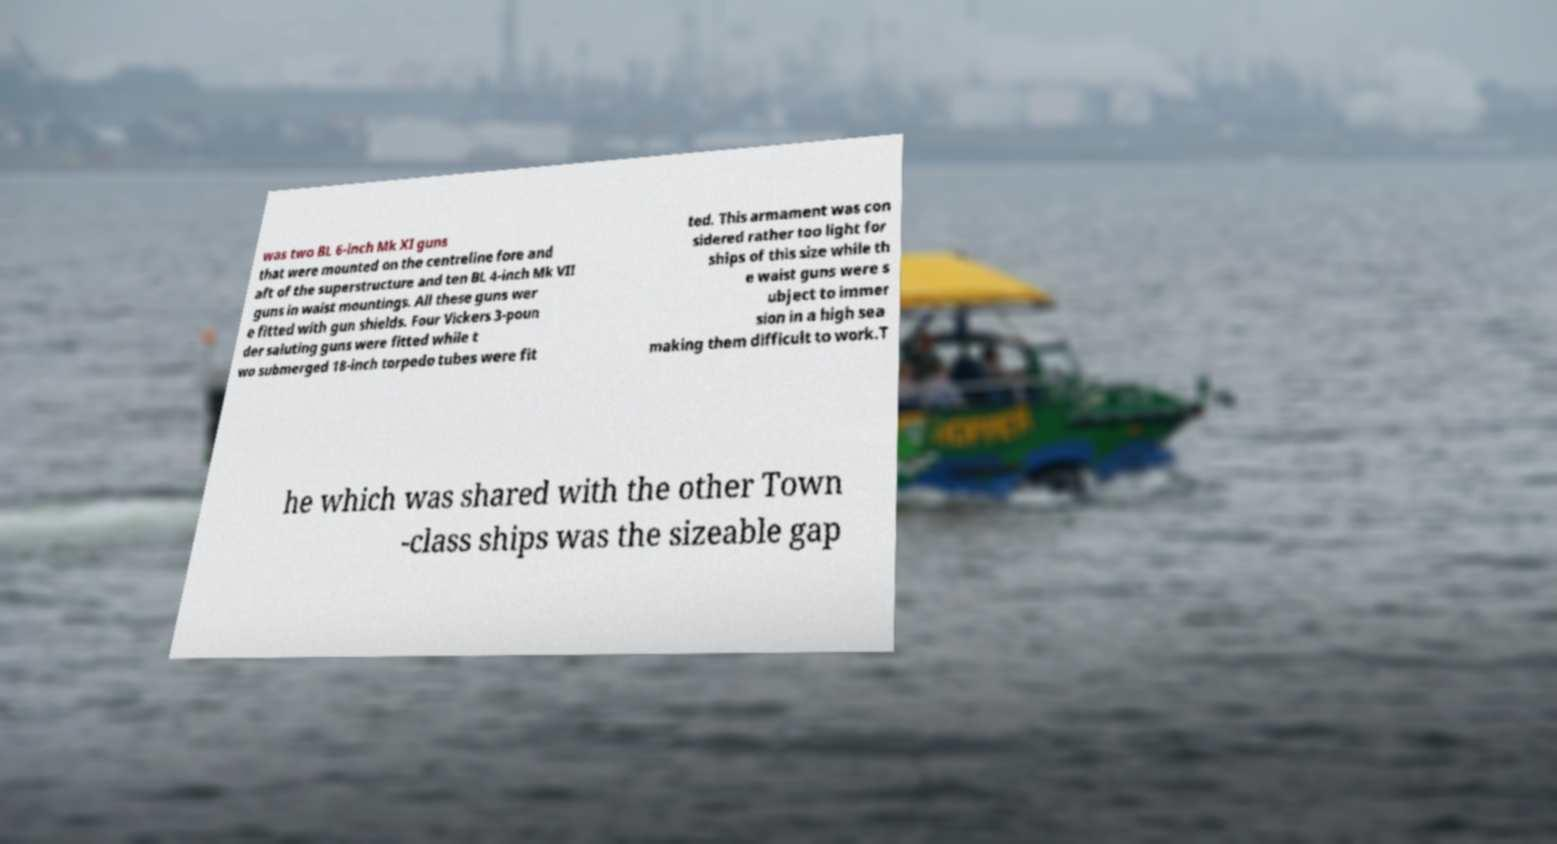Can you accurately transcribe the text from the provided image for me? was two BL 6-inch Mk XI guns that were mounted on the centreline fore and aft of the superstructure and ten BL 4-inch Mk VII guns in waist mountings. All these guns wer e fitted with gun shields. Four Vickers 3-poun der saluting guns were fitted while t wo submerged 18-inch torpedo tubes were fit ted. This armament was con sidered rather too light for ships of this size while th e waist guns were s ubject to immer sion in a high sea making them difficult to work.T he which was shared with the other Town -class ships was the sizeable gap 